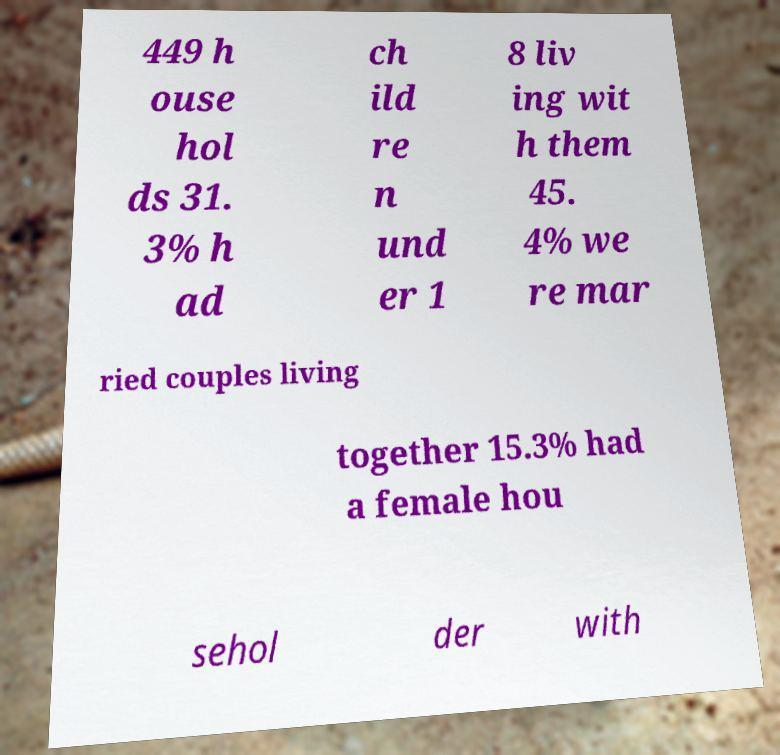Could you assist in decoding the text presented in this image and type it out clearly? 449 h ouse hol ds 31. 3% h ad ch ild re n und er 1 8 liv ing wit h them 45. 4% we re mar ried couples living together 15.3% had a female hou sehol der with 